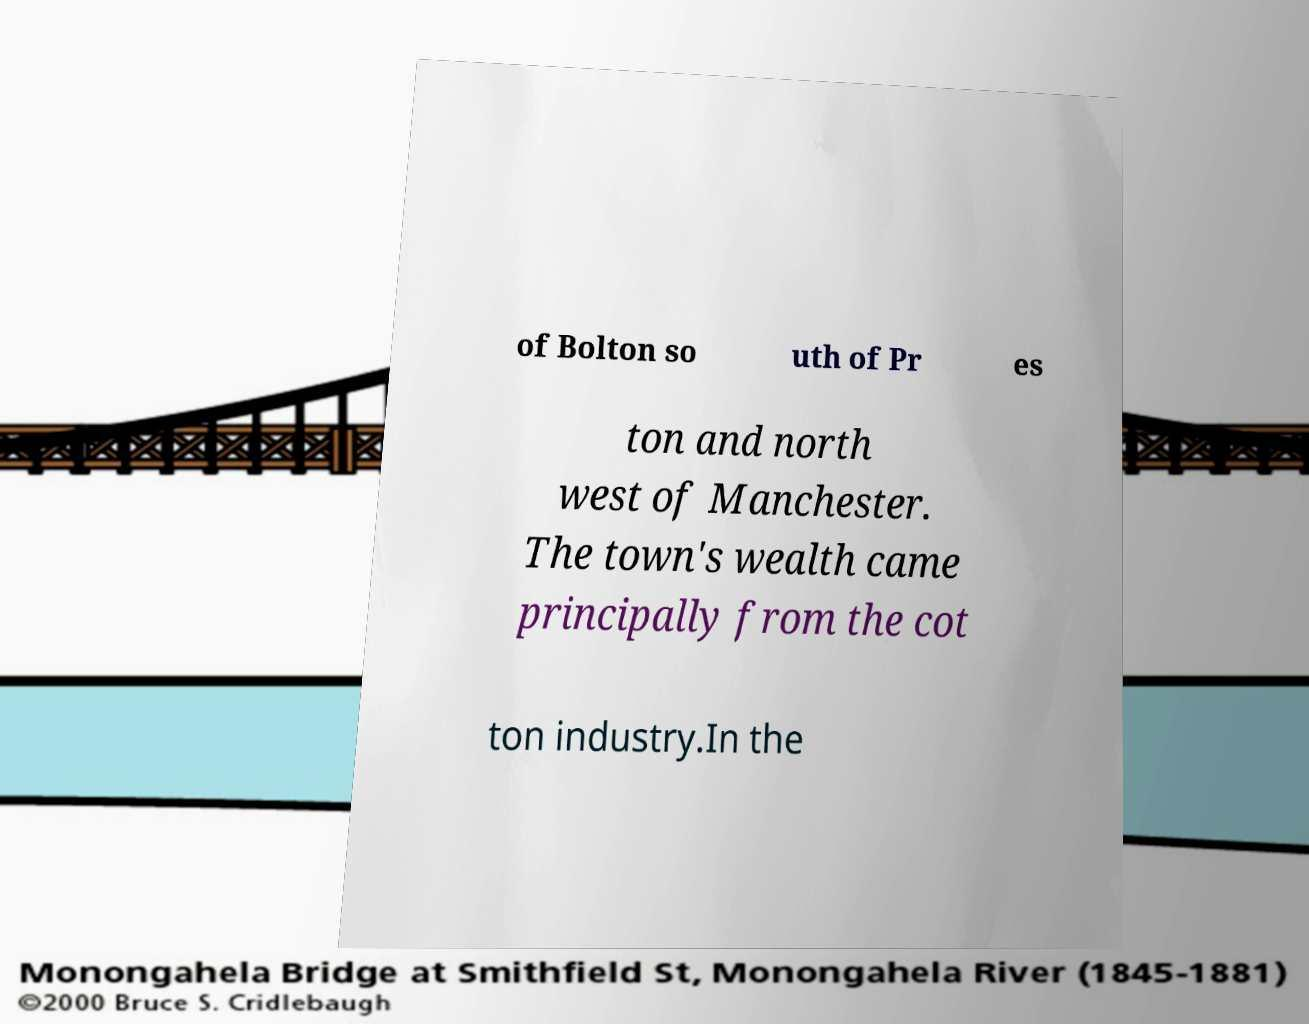Please read and relay the text visible in this image. What does it say? of Bolton so uth of Pr es ton and north west of Manchester. The town's wealth came principally from the cot ton industry.In the 